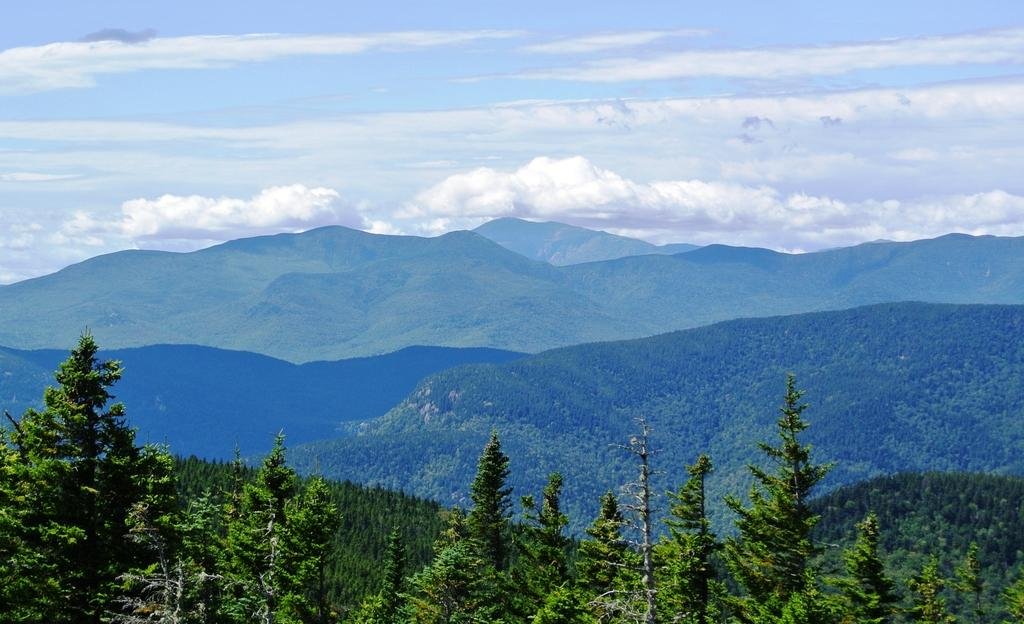What type of vegetation is at the bottom of the image? There are trees at the bottom of the image. What geographical features are in the middle of the image? There are hills in the middle of the image. What part of the natural environment is visible in the image? The sky is visible in the image. What can be seen in the sky? Clouds are present in the sky. What type of corn is being offered to the people in the image? There is no corn or people present in the image; it features trees, hills, and a sky with clouds. What ring is being worn by the tree in the image? There are no rings present in the image, as trees do not wear rings. 